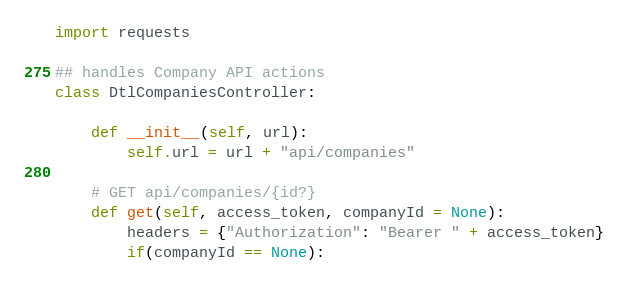<code> <loc_0><loc_0><loc_500><loc_500><_Python_>import requests

## handles Company API actions
class DtlCompaniesController:

    def __init__(self, url):
        self.url = url + "api/companies"

    # GET api/companies/{id?}
    def get(self, access_token, companyId = None):
        headers = {"Authorization": "Bearer " + access_token}
        if(companyId == None):</code> 